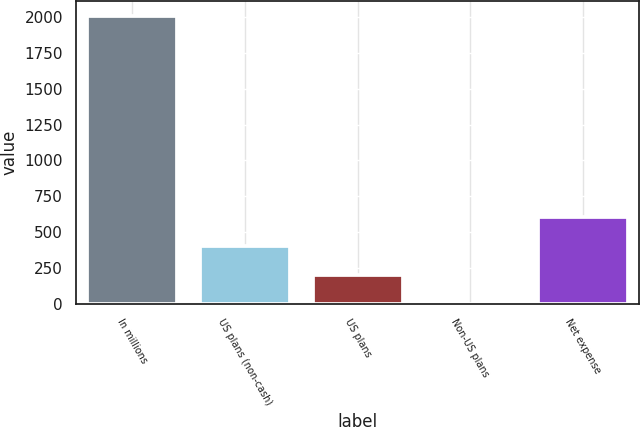<chart> <loc_0><loc_0><loc_500><loc_500><bar_chart><fcel>In millions<fcel>US plans (non-cash)<fcel>US plans<fcel>Non-US plans<fcel>Net expense<nl><fcel>2010<fcel>402.8<fcel>201.9<fcel>1<fcel>603.7<nl></chart> 